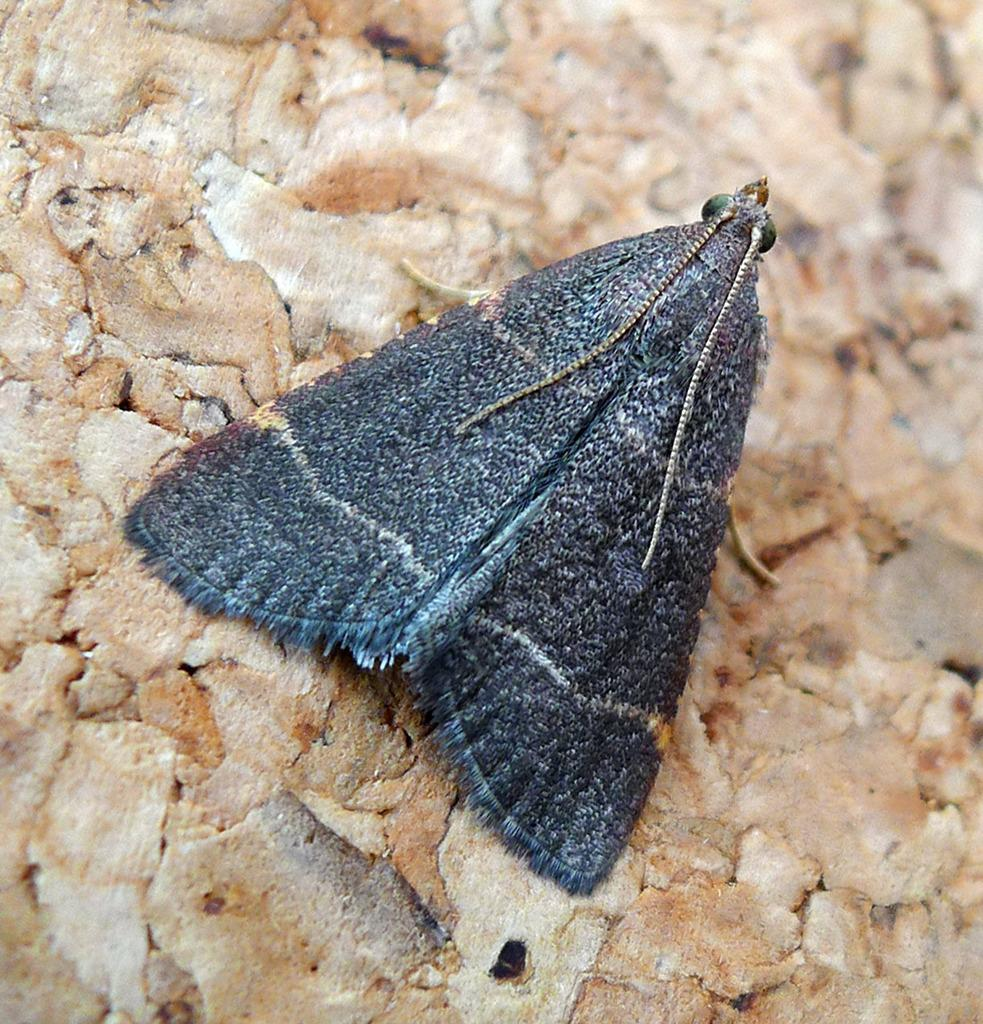What type of creature is present in the image? There is an insect in the image. Where is the insect located? The insect is on the ground. What type of apple is being served for lunch in the image? There is no apple or lunch depicted in the image; it only features an insect on the ground. 